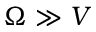<formula> <loc_0><loc_0><loc_500><loc_500>\Omega \gg V</formula> 